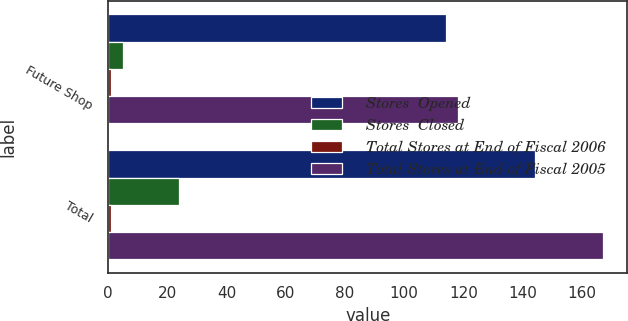Convert chart to OTSL. <chart><loc_0><loc_0><loc_500><loc_500><stacked_bar_chart><ecel><fcel>Future Shop<fcel>Total<nl><fcel>Stores  Opened<fcel>114<fcel>144<nl><fcel>Stores  Closed<fcel>5<fcel>24<nl><fcel>Total Stores at End of Fiscal 2006<fcel>1<fcel>1<nl><fcel>Total Stores at End of Fiscal 2005<fcel>118<fcel>167<nl></chart> 